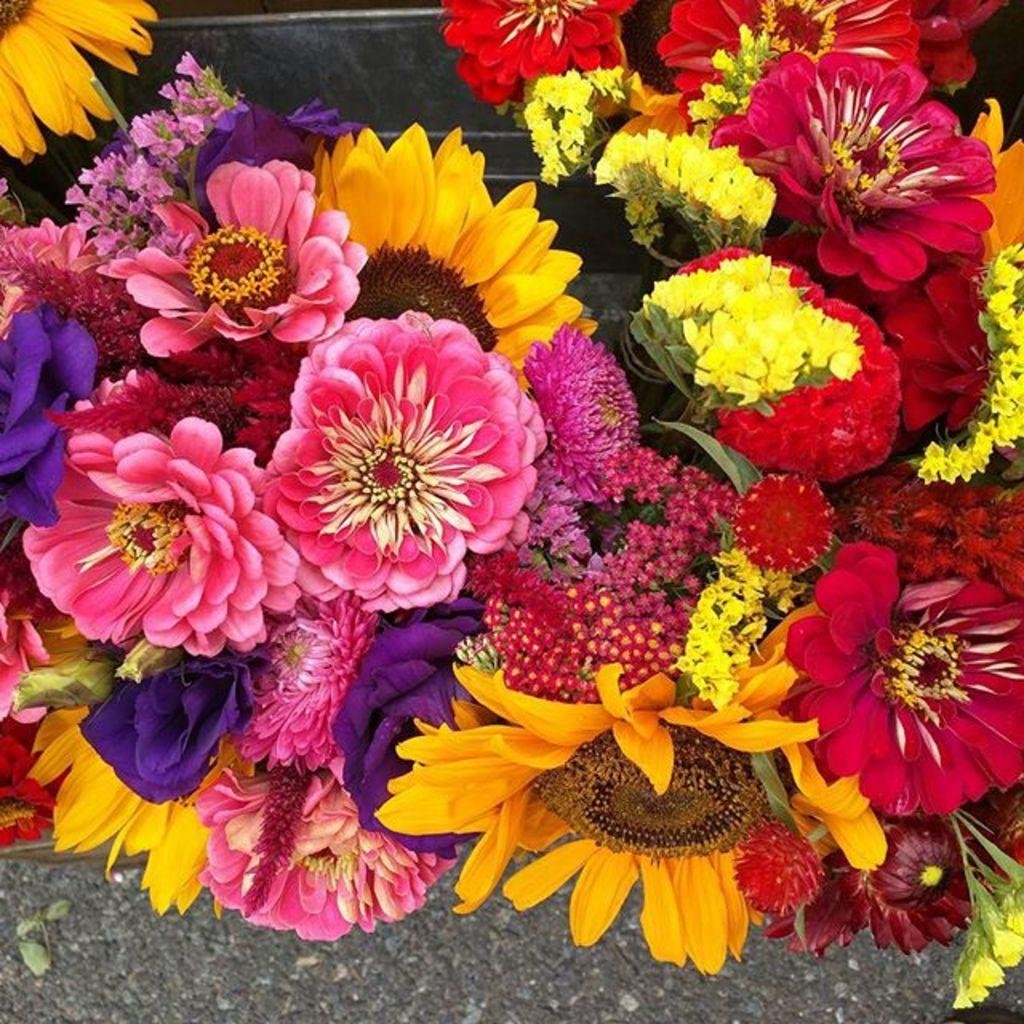What is present in the image? There are flowers in the image. Can you describe the flowers in the image? The flowers are of different types and have various colors. How many cakes are being attempted to be baked in the image? There are no cakes or baking activities present in the image; it features flowers of different types and colors. 